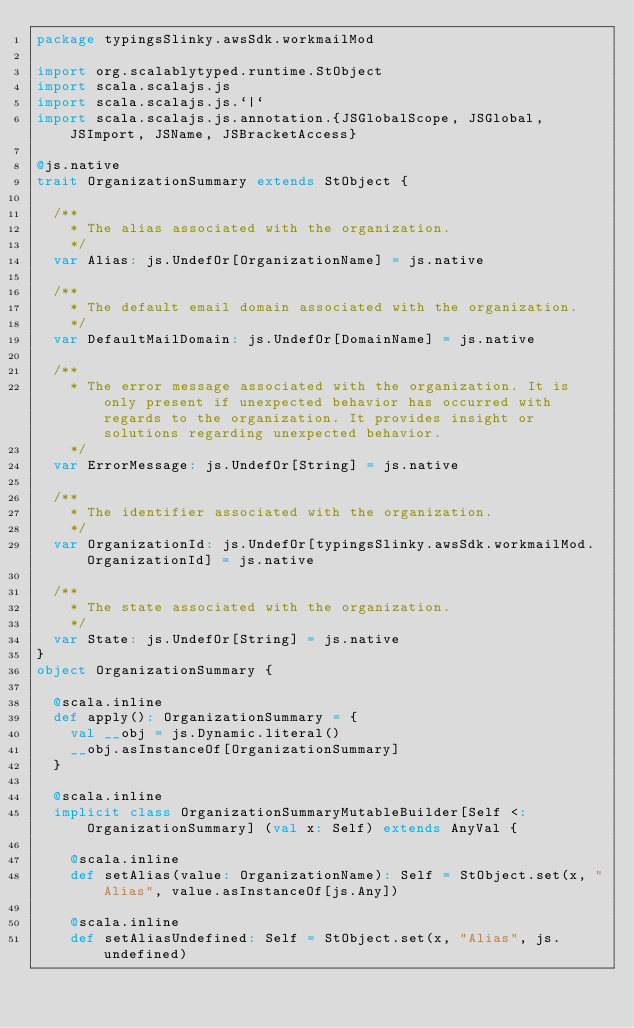Convert code to text. <code><loc_0><loc_0><loc_500><loc_500><_Scala_>package typingsSlinky.awsSdk.workmailMod

import org.scalablytyped.runtime.StObject
import scala.scalajs.js
import scala.scalajs.js.`|`
import scala.scalajs.js.annotation.{JSGlobalScope, JSGlobal, JSImport, JSName, JSBracketAccess}

@js.native
trait OrganizationSummary extends StObject {
  
  /**
    * The alias associated with the organization.
    */
  var Alias: js.UndefOr[OrganizationName] = js.native
  
  /**
    * The default email domain associated with the organization.
    */
  var DefaultMailDomain: js.UndefOr[DomainName] = js.native
  
  /**
    * The error message associated with the organization. It is only present if unexpected behavior has occurred with regards to the organization. It provides insight or solutions regarding unexpected behavior.
    */
  var ErrorMessage: js.UndefOr[String] = js.native
  
  /**
    * The identifier associated with the organization.
    */
  var OrganizationId: js.UndefOr[typingsSlinky.awsSdk.workmailMod.OrganizationId] = js.native
  
  /**
    * The state associated with the organization.
    */
  var State: js.UndefOr[String] = js.native
}
object OrganizationSummary {
  
  @scala.inline
  def apply(): OrganizationSummary = {
    val __obj = js.Dynamic.literal()
    __obj.asInstanceOf[OrganizationSummary]
  }
  
  @scala.inline
  implicit class OrganizationSummaryMutableBuilder[Self <: OrganizationSummary] (val x: Self) extends AnyVal {
    
    @scala.inline
    def setAlias(value: OrganizationName): Self = StObject.set(x, "Alias", value.asInstanceOf[js.Any])
    
    @scala.inline
    def setAliasUndefined: Self = StObject.set(x, "Alias", js.undefined)
    </code> 